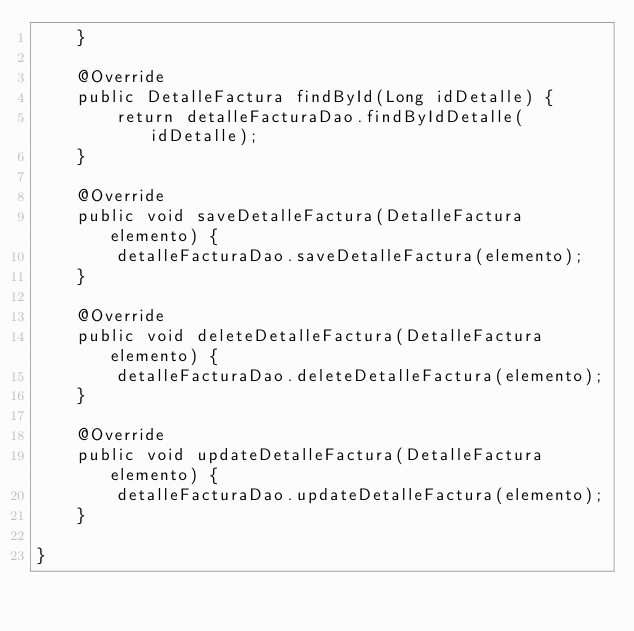<code> <loc_0><loc_0><loc_500><loc_500><_Java_>    }

    @Override
    public DetalleFactura findById(Long idDetalle) {
        return detalleFacturaDao.findByIdDetalle(idDetalle);
    }

    @Override
    public void saveDetalleFactura(DetalleFactura elemento) {
        detalleFacturaDao.saveDetalleFactura(elemento);
    }

    @Override
    public void deleteDetalleFactura(DetalleFactura elemento) {
        detalleFacturaDao.deleteDetalleFactura(elemento);
    }

    @Override
    public void updateDetalleFactura(DetalleFactura elemento) {
        detalleFacturaDao.updateDetalleFactura(elemento);
    }

}
</code> 